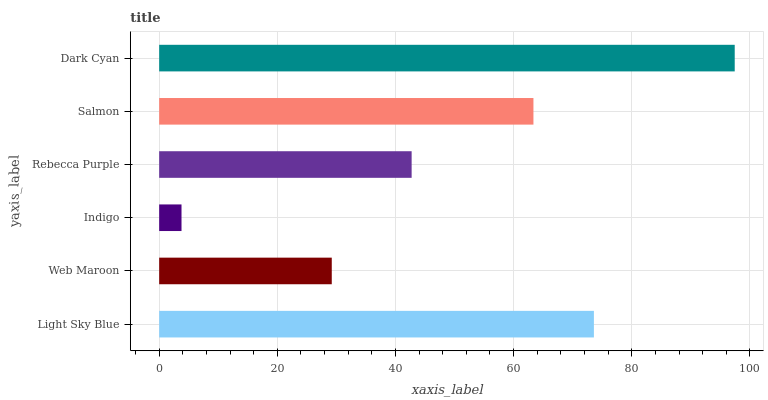Is Indigo the minimum?
Answer yes or no. Yes. Is Dark Cyan the maximum?
Answer yes or no. Yes. Is Web Maroon the minimum?
Answer yes or no. No. Is Web Maroon the maximum?
Answer yes or no. No. Is Light Sky Blue greater than Web Maroon?
Answer yes or no. Yes. Is Web Maroon less than Light Sky Blue?
Answer yes or no. Yes. Is Web Maroon greater than Light Sky Blue?
Answer yes or no. No. Is Light Sky Blue less than Web Maroon?
Answer yes or no. No. Is Salmon the high median?
Answer yes or no. Yes. Is Rebecca Purple the low median?
Answer yes or no. Yes. Is Light Sky Blue the high median?
Answer yes or no. No. Is Dark Cyan the low median?
Answer yes or no. No. 